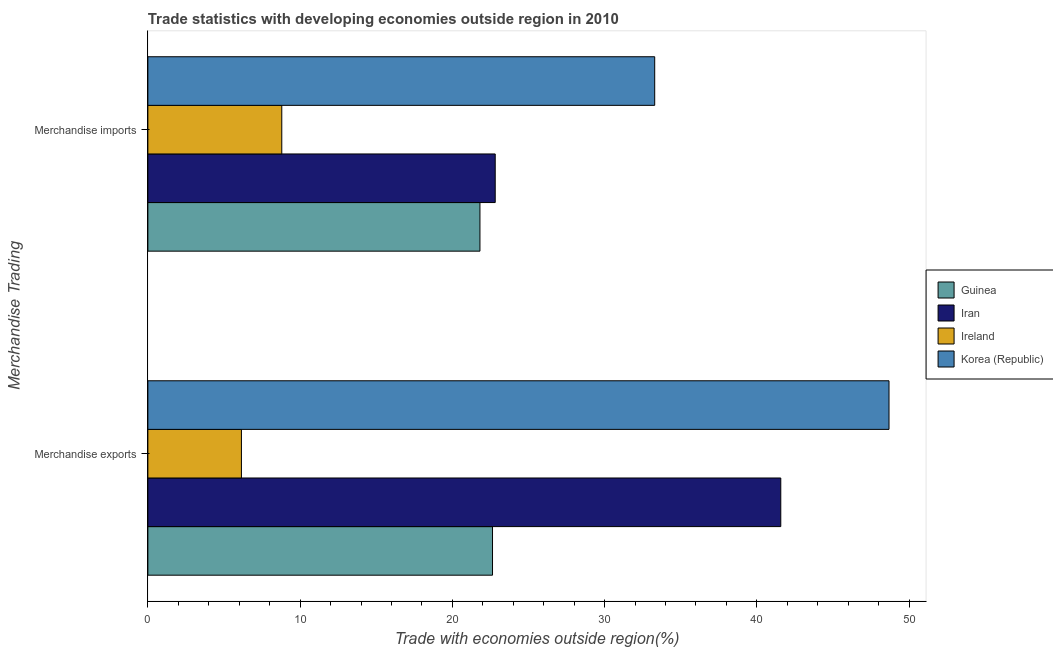How many different coloured bars are there?
Your response must be concise. 4. Are the number of bars per tick equal to the number of legend labels?
Your answer should be compact. Yes. Are the number of bars on each tick of the Y-axis equal?
Your response must be concise. Yes. What is the merchandise exports in Korea (Republic)?
Make the answer very short. 48.68. Across all countries, what is the maximum merchandise exports?
Keep it short and to the point. 48.68. Across all countries, what is the minimum merchandise imports?
Offer a very short reply. 8.8. In which country was the merchandise exports maximum?
Offer a terse response. Korea (Republic). In which country was the merchandise exports minimum?
Give a very brief answer. Ireland. What is the total merchandise imports in the graph?
Your answer should be very brief. 86.72. What is the difference between the merchandise imports in Guinea and that in Korea (Republic)?
Ensure brevity in your answer.  -11.48. What is the difference between the merchandise exports in Guinea and the merchandise imports in Ireland?
Keep it short and to the point. 13.84. What is the average merchandise exports per country?
Your answer should be compact. 29.76. What is the difference between the merchandise imports and merchandise exports in Korea (Republic)?
Your response must be concise. -15.39. In how many countries, is the merchandise exports greater than 42 %?
Provide a short and direct response. 1. What is the ratio of the merchandise imports in Guinea to that in Iran?
Ensure brevity in your answer.  0.96. Is the merchandise exports in Guinea less than that in Korea (Republic)?
Give a very brief answer. Yes. What does the 3rd bar from the top in Merchandise exports represents?
Your response must be concise. Iran. What does the 2nd bar from the bottom in Merchandise imports represents?
Your response must be concise. Iran. How many bars are there?
Offer a terse response. 8. What is the difference between two consecutive major ticks on the X-axis?
Make the answer very short. 10. Are the values on the major ticks of X-axis written in scientific E-notation?
Provide a succinct answer. No. Does the graph contain grids?
Provide a succinct answer. No. What is the title of the graph?
Give a very brief answer. Trade statistics with developing economies outside region in 2010. Does "Honduras" appear as one of the legend labels in the graph?
Make the answer very short. No. What is the label or title of the X-axis?
Ensure brevity in your answer.  Trade with economies outside region(%). What is the label or title of the Y-axis?
Make the answer very short. Merchandise Trading. What is the Trade with economies outside region(%) in Guinea in Merchandise exports?
Give a very brief answer. 22.64. What is the Trade with economies outside region(%) of Iran in Merchandise exports?
Offer a very short reply. 41.57. What is the Trade with economies outside region(%) of Ireland in Merchandise exports?
Keep it short and to the point. 6.15. What is the Trade with economies outside region(%) in Korea (Republic) in Merchandise exports?
Keep it short and to the point. 48.68. What is the Trade with economies outside region(%) in Guinea in Merchandise imports?
Your answer should be very brief. 21.81. What is the Trade with economies outside region(%) of Iran in Merchandise imports?
Make the answer very short. 22.82. What is the Trade with economies outside region(%) of Ireland in Merchandise imports?
Provide a short and direct response. 8.8. What is the Trade with economies outside region(%) in Korea (Republic) in Merchandise imports?
Give a very brief answer. 33.29. Across all Merchandise Trading, what is the maximum Trade with economies outside region(%) in Guinea?
Offer a very short reply. 22.64. Across all Merchandise Trading, what is the maximum Trade with economies outside region(%) in Iran?
Make the answer very short. 41.57. Across all Merchandise Trading, what is the maximum Trade with economies outside region(%) of Ireland?
Ensure brevity in your answer.  8.8. Across all Merchandise Trading, what is the maximum Trade with economies outside region(%) of Korea (Republic)?
Provide a succinct answer. 48.68. Across all Merchandise Trading, what is the minimum Trade with economies outside region(%) of Guinea?
Ensure brevity in your answer.  21.81. Across all Merchandise Trading, what is the minimum Trade with economies outside region(%) in Iran?
Give a very brief answer. 22.82. Across all Merchandise Trading, what is the minimum Trade with economies outside region(%) in Ireland?
Offer a very short reply. 6.15. Across all Merchandise Trading, what is the minimum Trade with economies outside region(%) in Korea (Republic)?
Your answer should be very brief. 33.29. What is the total Trade with economies outside region(%) of Guinea in the graph?
Make the answer very short. 44.45. What is the total Trade with economies outside region(%) of Iran in the graph?
Offer a very short reply. 64.39. What is the total Trade with economies outside region(%) of Ireland in the graph?
Ensure brevity in your answer.  14.94. What is the total Trade with economies outside region(%) of Korea (Republic) in the graph?
Ensure brevity in your answer.  81.98. What is the difference between the Trade with economies outside region(%) of Guinea in Merchandise exports and that in Merchandise imports?
Your answer should be very brief. 0.83. What is the difference between the Trade with economies outside region(%) in Iran in Merchandise exports and that in Merchandise imports?
Give a very brief answer. 18.76. What is the difference between the Trade with economies outside region(%) of Ireland in Merchandise exports and that in Merchandise imports?
Your answer should be very brief. -2.65. What is the difference between the Trade with economies outside region(%) in Korea (Republic) in Merchandise exports and that in Merchandise imports?
Keep it short and to the point. 15.39. What is the difference between the Trade with economies outside region(%) in Guinea in Merchandise exports and the Trade with economies outside region(%) in Iran in Merchandise imports?
Offer a very short reply. -0.18. What is the difference between the Trade with economies outside region(%) of Guinea in Merchandise exports and the Trade with economies outside region(%) of Ireland in Merchandise imports?
Your answer should be compact. 13.84. What is the difference between the Trade with economies outside region(%) in Guinea in Merchandise exports and the Trade with economies outside region(%) in Korea (Republic) in Merchandise imports?
Give a very brief answer. -10.65. What is the difference between the Trade with economies outside region(%) of Iran in Merchandise exports and the Trade with economies outside region(%) of Ireland in Merchandise imports?
Provide a succinct answer. 32.78. What is the difference between the Trade with economies outside region(%) in Iran in Merchandise exports and the Trade with economies outside region(%) in Korea (Republic) in Merchandise imports?
Give a very brief answer. 8.28. What is the difference between the Trade with economies outside region(%) of Ireland in Merchandise exports and the Trade with economies outside region(%) of Korea (Republic) in Merchandise imports?
Your response must be concise. -27.15. What is the average Trade with economies outside region(%) in Guinea per Merchandise Trading?
Provide a short and direct response. 22.23. What is the average Trade with economies outside region(%) in Iran per Merchandise Trading?
Your answer should be compact. 32.2. What is the average Trade with economies outside region(%) in Ireland per Merchandise Trading?
Keep it short and to the point. 7.47. What is the average Trade with economies outside region(%) of Korea (Republic) per Merchandise Trading?
Provide a short and direct response. 40.99. What is the difference between the Trade with economies outside region(%) in Guinea and Trade with economies outside region(%) in Iran in Merchandise exports?
Your answer should be compact. -18.93. What is the difference between the Trade with economies outside region(%) in Guinea and Trade with economies outside region(%) in Ireland in Merchandise exports?
Offer a terse response. 16.49. What is the difference between the Trade with economies outside region(%) in Guinea and Trade with economies outside region(%) in Korea (Republic) in Merchandise exports?
Make the answer very short. -26.05. What is the difference between the Trade with economies outside region(%) in Iran and Trade with economies outside region(%) in Ireland in Merchandise exports?
Offer a very short reply. 35.43. What is the difference between the Trade with economies outside region(%) of Iran and Trade with economies outside region(%) of Korea (Republic) in Merchandise exports?
Offer a very short reply. -7.11. What is the difference between the Trade with economies outside region(%) in Ireland and Trade with economies outside region(%) in Korea (Republic) in Merchandise exports?
Keep it short and to the point. -42.54. What is the difference between the Trade with economies outside region(%) in Guinea and Trade with economies outside region(%) in Iran in Merchandise imports?
Your response must be concise. -1. What is the difference between the Trade with economies outside region(%) in Guinea and Trade with economies outside region(%) in Ireland in Merchandise imports?
Your answer should be very brief. 13.02. What is the difference between the Trade with economies outside region(%) in Guinea and Trade with economies outside region(%) in Korea (Republic) in Merchandise imports?
Your answer should be compact. -11.48. What is the difference between the Trade with economies outside region(%) of Iran and Trade with economies outside region(%) of Ireland in Merchandise imports?
Your answer should be very brief. 14.02. What is the difference between the Trade with economies outside region(%) in Iran and Trade with economies outside region(%) in Korea (Republic) in Merchandise imports?
Give a very brief answer. -10.48. What is the difference between the Trade with economies outside region(%) in Ireland and Trade with economies outside region(%) in Korea (Republic) in Merchandise imports?
Provide a succinct answer. -24.5. What is the ratio of the Trade with economies outside region(%) in Guinea in Merchandise exports to that in Merchandise imports?
Ensure brevity in your answer.  1.04. What is the ratio of the Trade with economies outside region(%) in Iran in Merchandise exports to that in Merchandise imports?
Your answer should be very brief. 1.82. What is the ratio of the Trade with economies outside region(%) of Ireland in Merchandise exports to that in Merchandise imports?
Make the answer very short. 0.7. What is the ratio of the Trade with economies outside region(%) of Korea (Republic) in Merchandise exports to that in Merchandise imports?
Provide a succinct answer. 1.46. What is the difference between the highest and the second highest Trade with economies outside region(%) of Guinea?
Provide a succinct answer. 0.83. What is the difference between the highest and the second highest Trade with economies outside region(%) of Iran?
Provide a succinct answer. 18.76. What is the difference between the highest and the second highest Trade with economies outside region(%) in Ireland?
Make the answer very short. 2.65. What is the difference between the highest and the second highest Trade with economies outside region(%) of Korea (Republic)?
Make the answer very short. 15.39. What is the difference between the highest and the lowest Trade with economies outside region(%) in Guinea?
Keep it short and to the point. 0.83. What is the difference between the highest and the lowest Trade with economies outside region(%) of Iran?
Your response must be concise. 18.76. What is the difference between the highest and the lowest Trade with economies outside region(%) in Ireland?
Offer a very short reply. 2.65. What is the difference between the highest and the lowest Trade with economies outside region(%) of Korea (Republic)?
Make the answer very short. 15.39. 